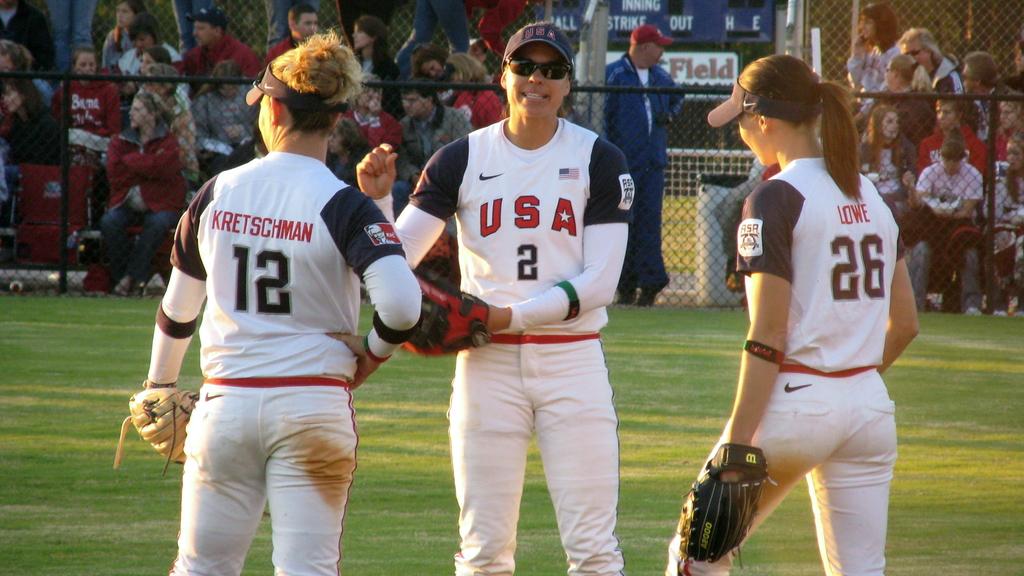What is the jersey number of the player on the right?
Your answer should be very brief. 26. 